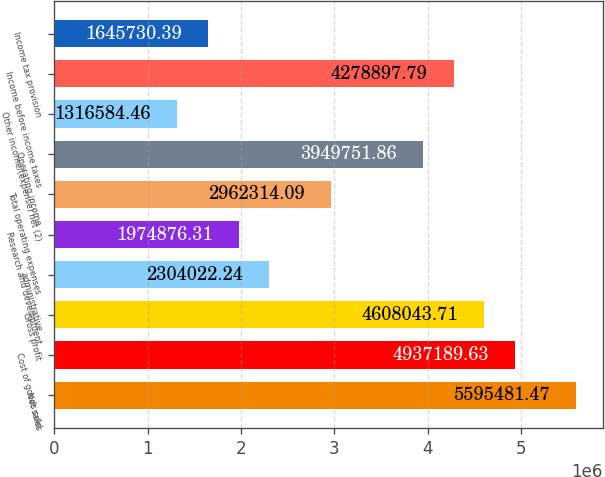Convert chart. <chart><loc_0><loc_0><loc_500><loc_500><bar_chart><fcel>Net sales<fcel>Cost of goods sold<fcel>Gross profit<fcel>administrative<fcel>Research and development<fcel>Total operating expenses<fcel>Operating income<fcel>Other income/(expense) net (2)<fcel>Income before income taxes<fcel>Income tax provision<nl><fcel>5.59548e+06<fcel>4.93719e+06<fcel>4.60804e+06<fcel>2.30402e+06<fcel>1.97488e+06<fcel>2.96231e+06<fcel>3.94975e+06<fcel>1.31658e+06<fcel>4.2789e+06<fcel>1.64573e+06<nl></chart> 